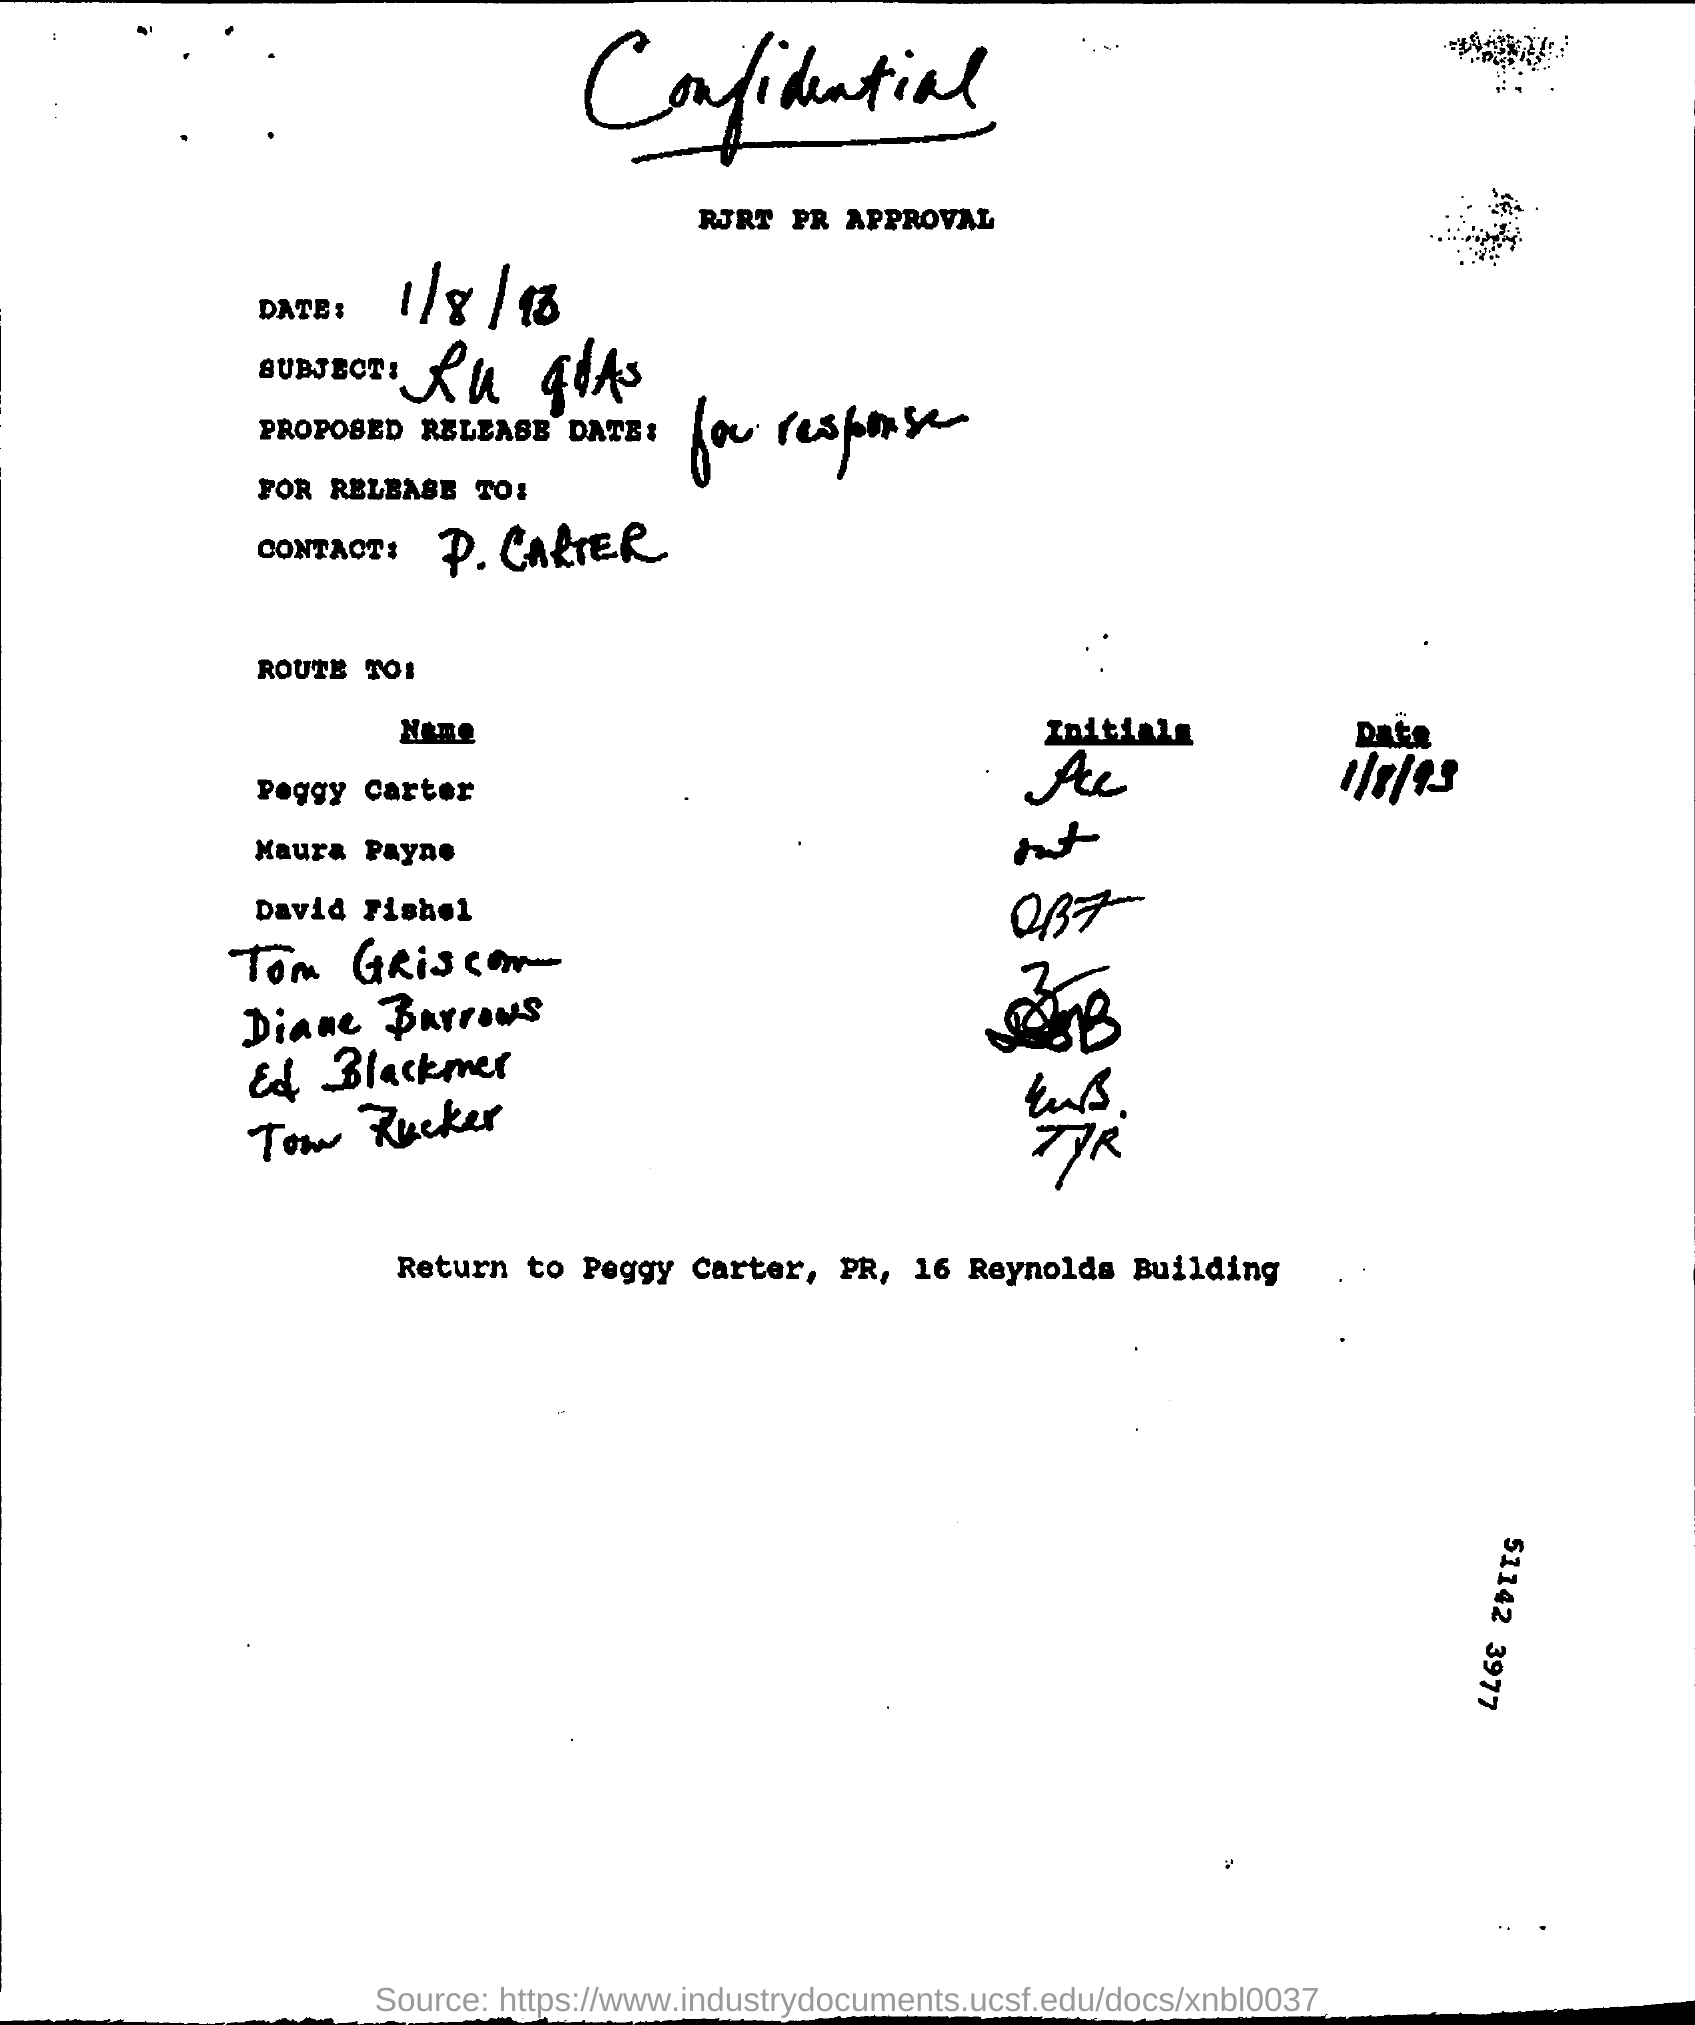What is the date mentioned in this letter?
Offer a terse response. 1/8/93. What is the contact person name mentioned in letter?
Offer a terse response. P. carter. 